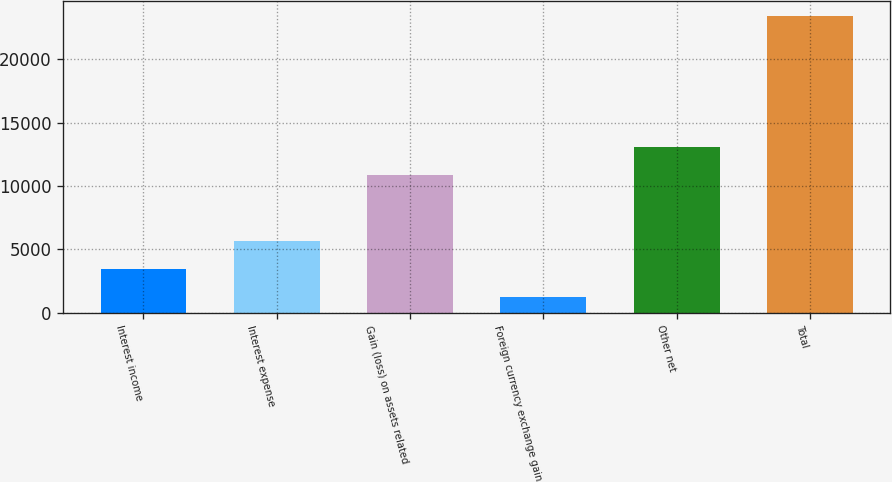<chart> <loc_0><loc_0><loc_500><loc_500><bar_chart><fcel>Interest income<fcel>Interest expense<fcel>Gain (loss) on assets related<fcel>Foreign currency exchange gain<fcel>Other net<fcel>Total<nl><fcel>3418<fcel>5641<fcel>10856<fcel>1195<fcel>13079<fcel>23425<nl></chart> 